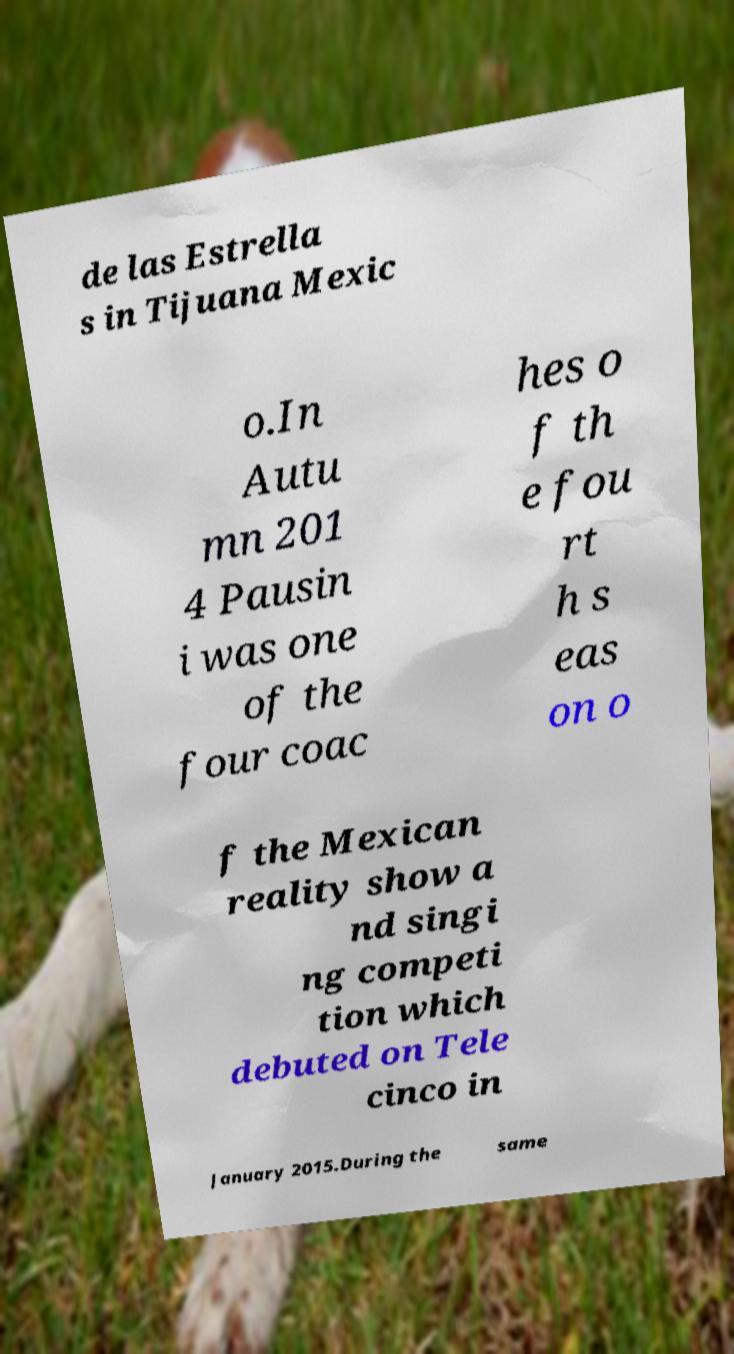Could you extract and type out the text from this image? de las Estrella s in Tijuana Mexic o.In Autu mn 201 4 Pausin i was one of the four coac hes o f th e fou rt h s eas on o f the Mexican reality show a nd singi ng competi tion which debuted on Tele cinco in January 2015.During the same 